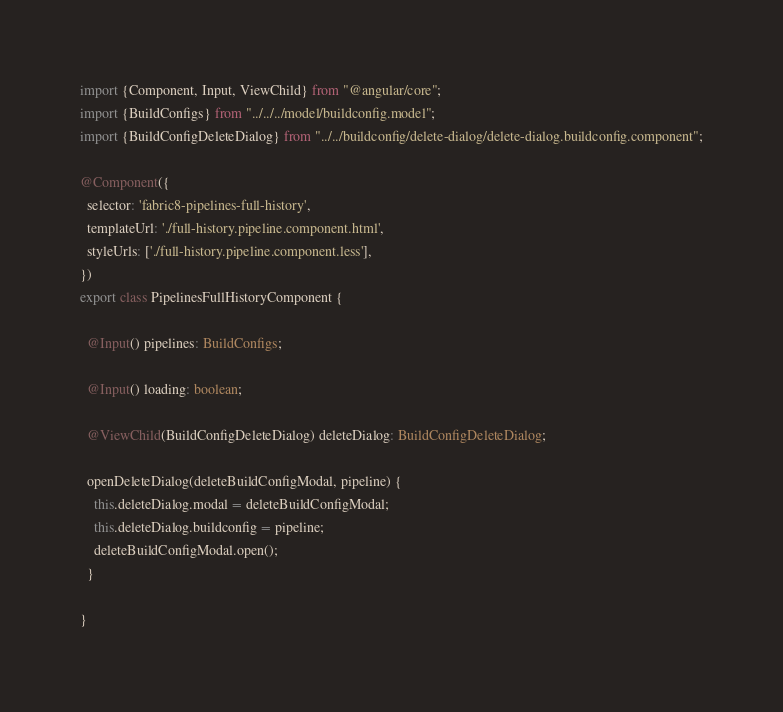Convert code to text. <code><loc_0><loc_0><loc_500><loc_500><_TypeScript_>import {Component, Input, ViewChild} from "@angular/core";
import {BuildConfigs} from "../../../model/buildconfig.model";
import {BuildConfigDeleteDialog} from "../../buildconfig/delete-dialog/delete-dialog.buildconfig.component";

@Component({
  selector: 'fabric8-pipelines-full-history',
  templateUrl: './full-history.pipeline.component.html',
  styleUrls: ['./full-history.pipeline.component.less'],
})
export class PipelinesFullHistoryComponent {

  @Input() pipelines: BuildConfigs;

  @Input() loading: boolean;

  @ViewChild(BuildConfigDeleteDialog) deleteDialog: BuildConfigDeleteDialog;

  openDeleteDialog(deleteBuildConfigModal, pipeline) {
    this.deleteDialog.modal = deleteBuildConfigModal;
    this.deleteDialog.buildconfig = pipeline;
    deleteBuildConfigModal.open();
  }

}
</code> 